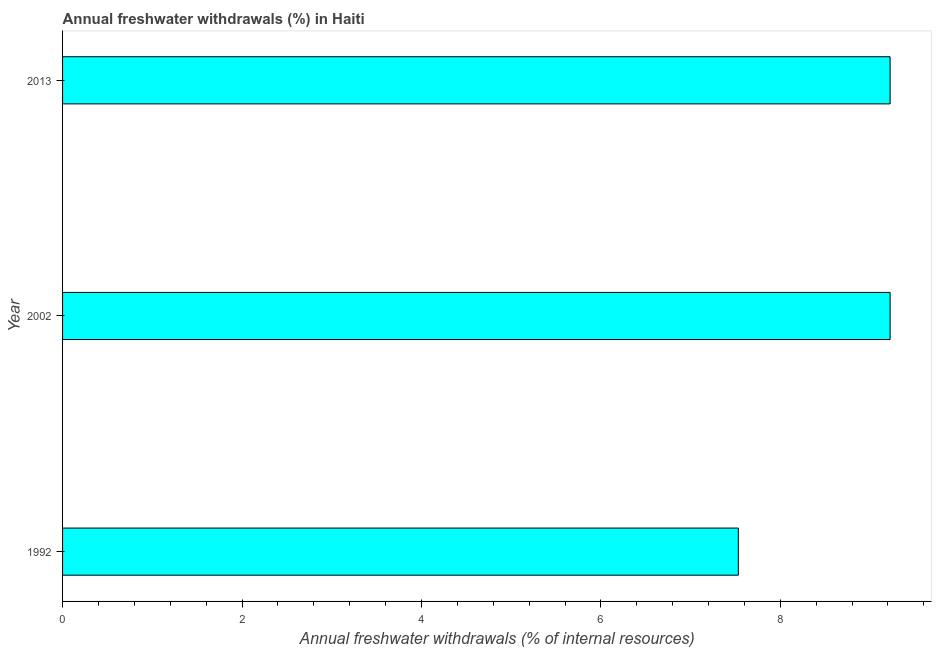Does the graph contain any zero values?
Give a very brief answer. No. What is the title of the graph?
Offer a very short reply. Annual freshwater withdrawals (%) in Haiti. What is the label or title of the X-axis?
Your answer should be very brief. Annual freshwater withdrawals (% of internal resources). What is the annual freshwater withdrawals in 1992?
Ensure brevity in your answer.  7.53. Across all years, what is the maximum annual freshwater withdrawals?
Your answer should be very brief. 9.22. Across all years, what is the minimum annual freshwater withdrawals?
Provide a short and direct response. 7.53. In which year was the annual freshwater withdrawals maximum?
Your answer should be very brief. 2002. In which year was the annual freshwater withdrawals minimum?
Your answer should be very brief. 1992. What is the sum of the annual freshwater withdrawals?
Offer a terse response. 25.98. What is the difference between the annual freshwater withdrawals in 1992 and 2013?
Make the answer very short. -1.69. What is the average annual freshwater withdrawals per year?
Offer a terse response. 8.66. What is the median annual freshwater withdrawals?
Your answer should be compact. 9.22. Do a majority of the years between 2002 and 1992 (inclusive) have annual freshwater withdrawals greater than 4.4 %?
Make the answer very short. No. What is the ratio of the annual freshwater withdrawals in 1992 to that in 2013?
Give a very brief answer. 0.82. Is the annual freshwater withdrawals in 1992 less than that in 2002?
Make the answer very short. Yes. Is the sum of the annual freshwater withdrawals in 1992 and 2013 greater than the maximum annual freshwater withdrawals across all years?
Offer a terse response. Yes. What is the difference between the highest and the lowest annual freshwater withdrawals?
Provide a succinct answer. 1.69. In how many years, is the annual freshwater withdrawals greater than the average annual freshwater withdrawals taken over all years?
Your answer should be very brief. 2. How many bars are there?
Make the answer very short. 3. Are all the bars in the graph horizontal?
Your answer should be compact. Yes. How many years are there in the graph?
Offer a terse response. 3. What is the Annual freshwater withdrawals (% of internal resources) of 1992?
Provide a succinct answer. 7.53. What is the Annual freshwater withdrawals (% of internal resources) in 2002?
Keep it short and to the point. 9.22. What is the Annual freshwater withdrawals (% of internal resources) in 2013?
Offer a very short reply. 9.22. What is the difference between the Annual freshwater withdrawals (% of internal resources) in 1992 and 2002?
Make the answer very short. -1.69. What is the difference between the Annual freshwater withdrawals (% of internal resources) in 1992 and 2013?
Your response must be concise. -1.69. What is the difference between the Annual freshwater withdrawals (% of internal resources) in 2002 and 2013?
Your answer should be compact. 0. What is the ratio of the Annual freshwater withdrawals (% of internal resources) in 1992 to that in 2002?
Make the answer very short. 0.82. What is the ratio of the Annual freshwater withdrawals (% of internal resources) in 1992 to that in 2013?
Ensure brevity in your answer.  0.82. 